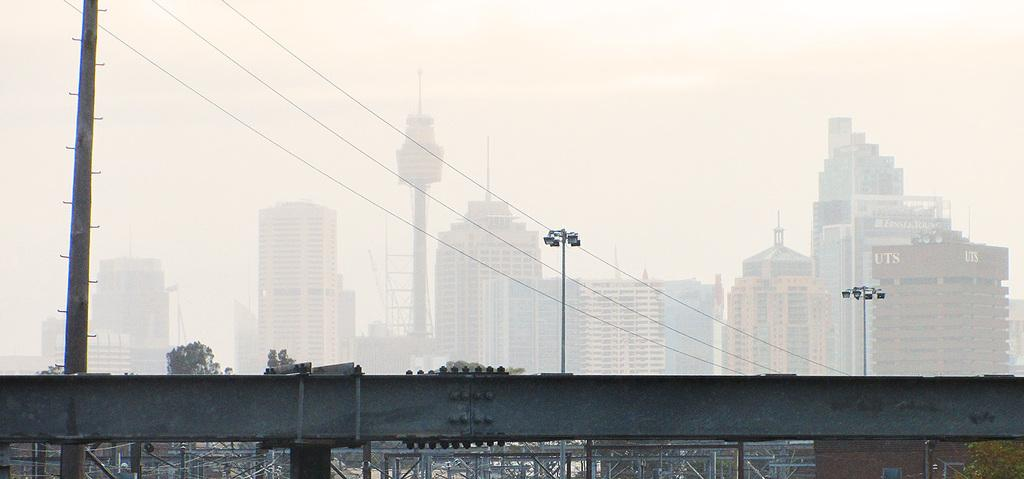What type of structures can be seen in the image? There are buildings in the image. What are the vertical structures with lights on them called? Light poles are present in the image. What is the tall, thin structure in the image? There is a pole in the image. What connects the light poles and the pole in the image? Wires are visible in the image. What type of barrier is present in the image? Fencing is present in the image. What type of vegetation is in the image? Trees are in the image. What is the color of the sky in the image? The sky appears to be white in color. How many nails are used to hold the trade in place in the image? There is no trade present in the image, and therefore no nails are used to hold it in place. What type of glue is being used to attach the leaves to the trees in the image? There are no leaves being attached to the trees in the image, and therefore no glue is being used. 